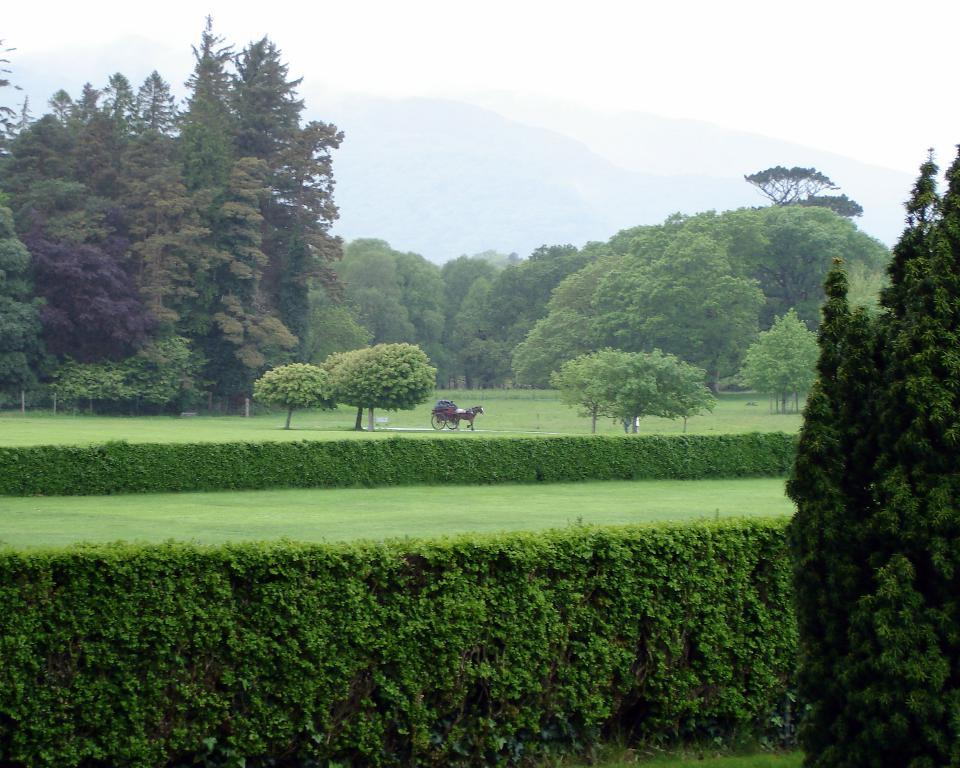What is located in the center of the image? There is a vehicle and a horse in the center of the image. What type of vegetation can be seen in the image? There are plants, grass, and trees in the image. What is visible in the background of the image? There are mountains in the background of the image. What type of soup can be seen in the image? There is no soup present in the image. How many pages are visible in the image? There are no pages present in the image. 